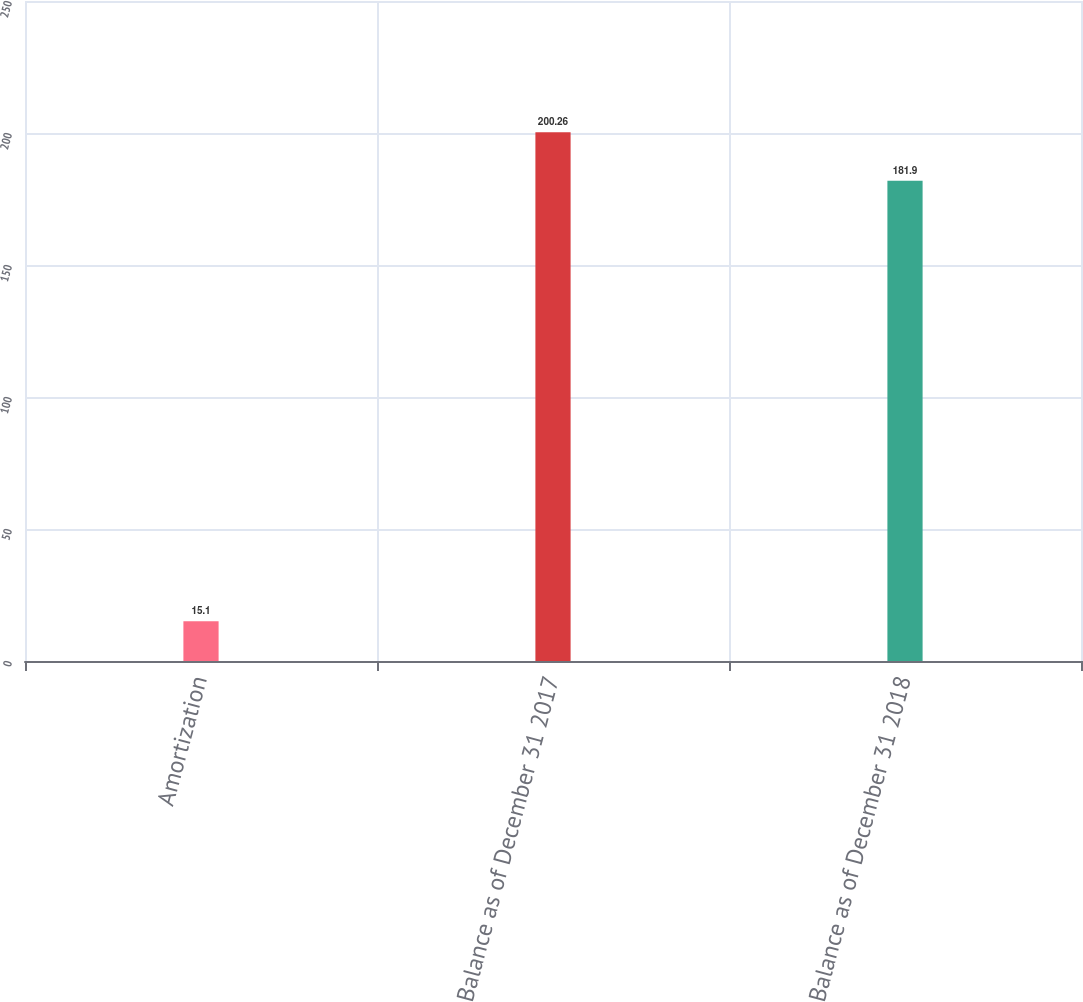Convert chart. <chart><loc_0><loc_0><loc_500><loc_500><bar_chart><fcel>Amortization<fcel>Balance as of December 31 2017<fcel>Balance as of December 31 2018<nl><fcel>15.1<fcel>200.26<fcel>181.9<nl></chart> 